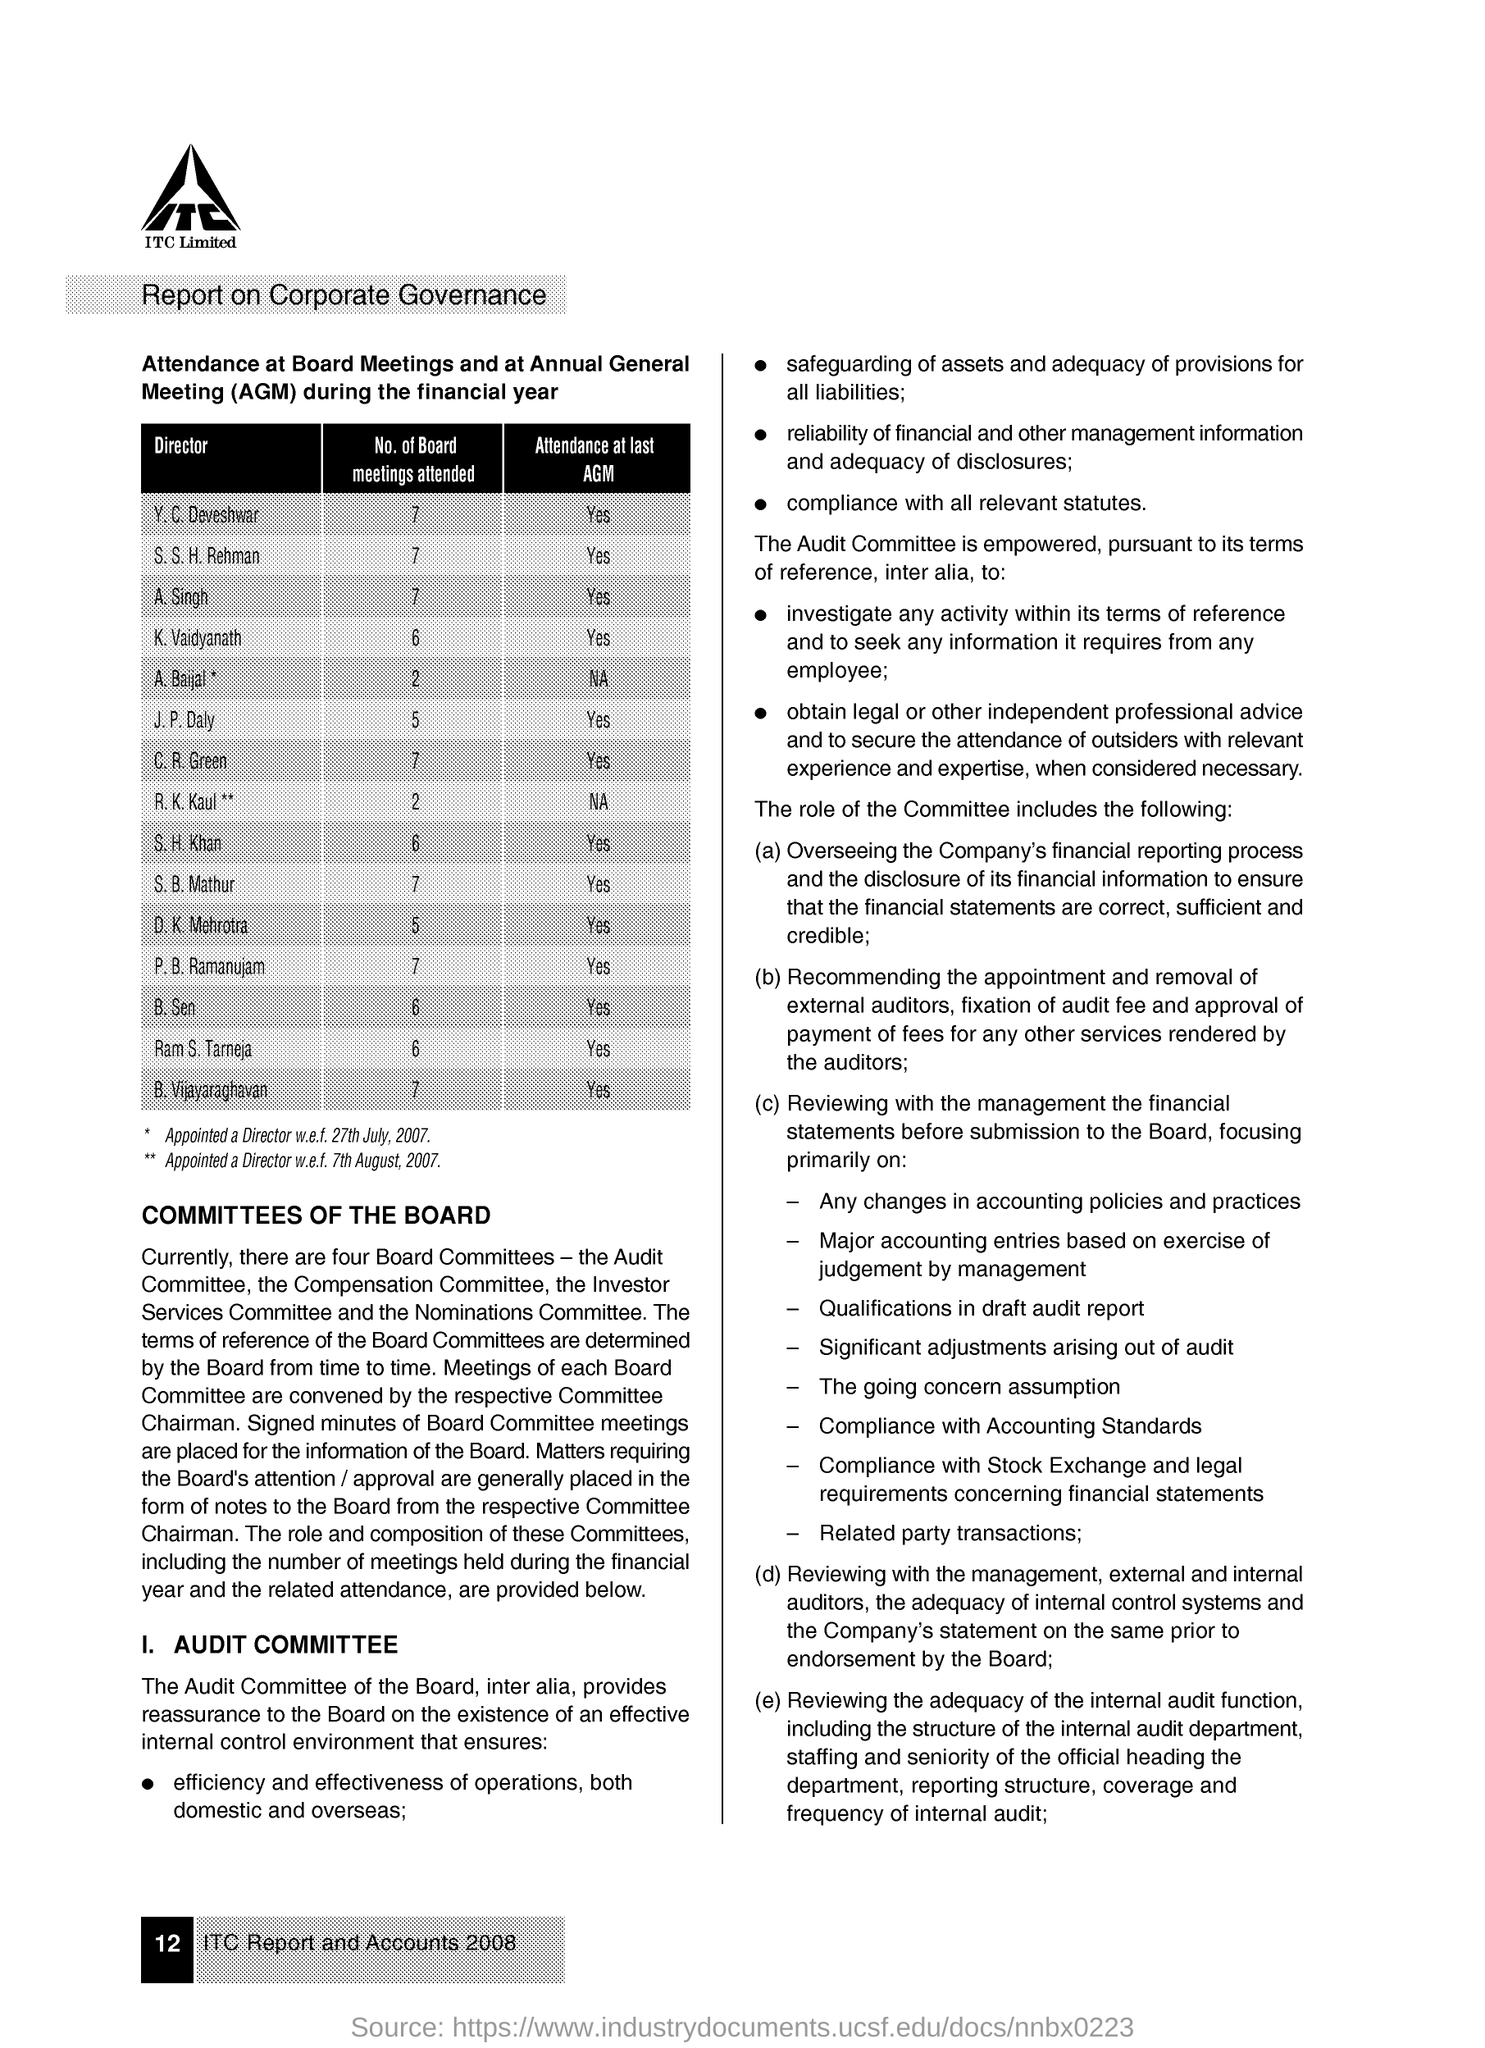Identify some key points in this picture. B. Sen has attended a total of 6 board meetings. The number of board meetings attended by K. Vaidyanath is six. S. B. Mathur has attended a total of 7 board meetings. A. Singh has attended a total of 7 board meetings. Y. C. Deveshwar attended 7 board meetings. 